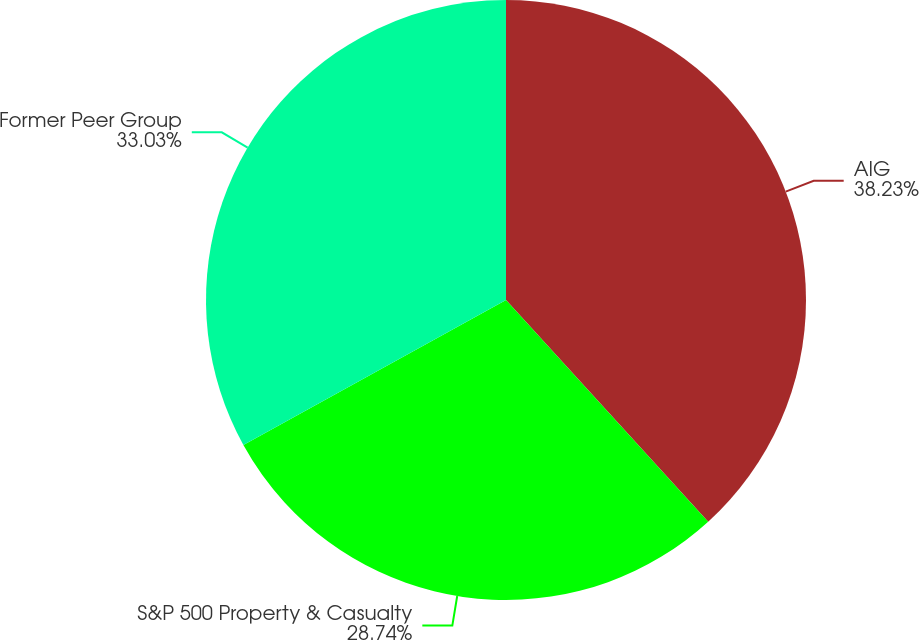Convert chart. <chart><loc_0><loc_0><loc_500><loc_500><pie_chart><fcel>AIG<fcel>S&P 500 Property & Casualty<fcel>Former Peer Group<nl><fcel>38.23%<fcel>28.74%<fcel>33.03%<nl></chart> 